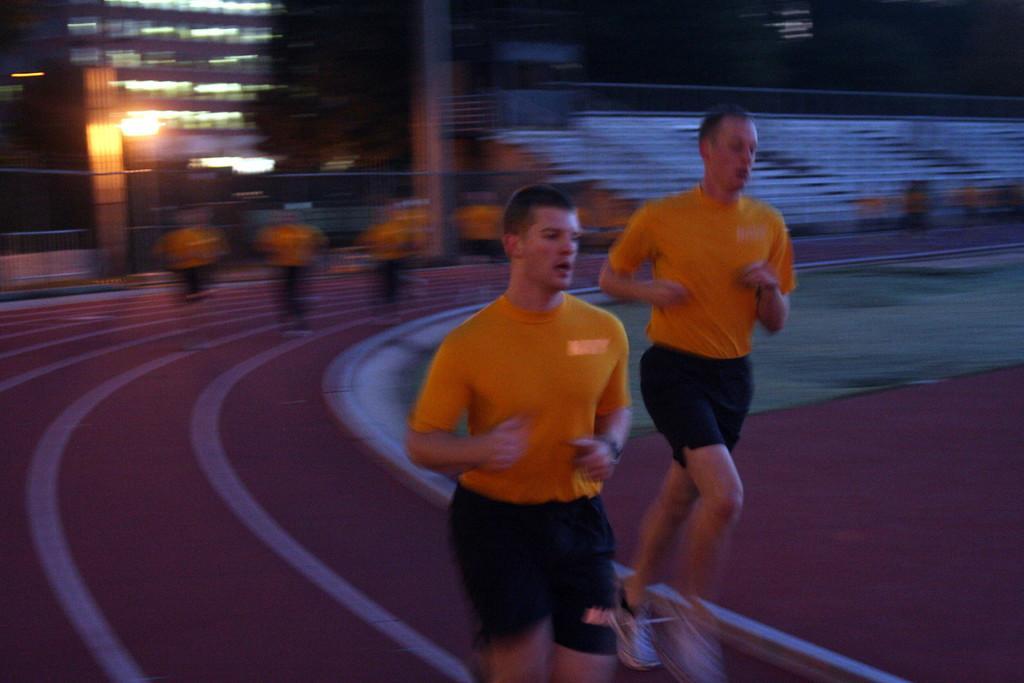Could you give a brief overview of what you see in this image? In this image, in the middle there is a man, he wears a t shirt, trouser, he is running. On the right there is a man, he wears a t shirt, trouser, shoes, he is running. In the background there are people, ground, building, lights, staircase. 